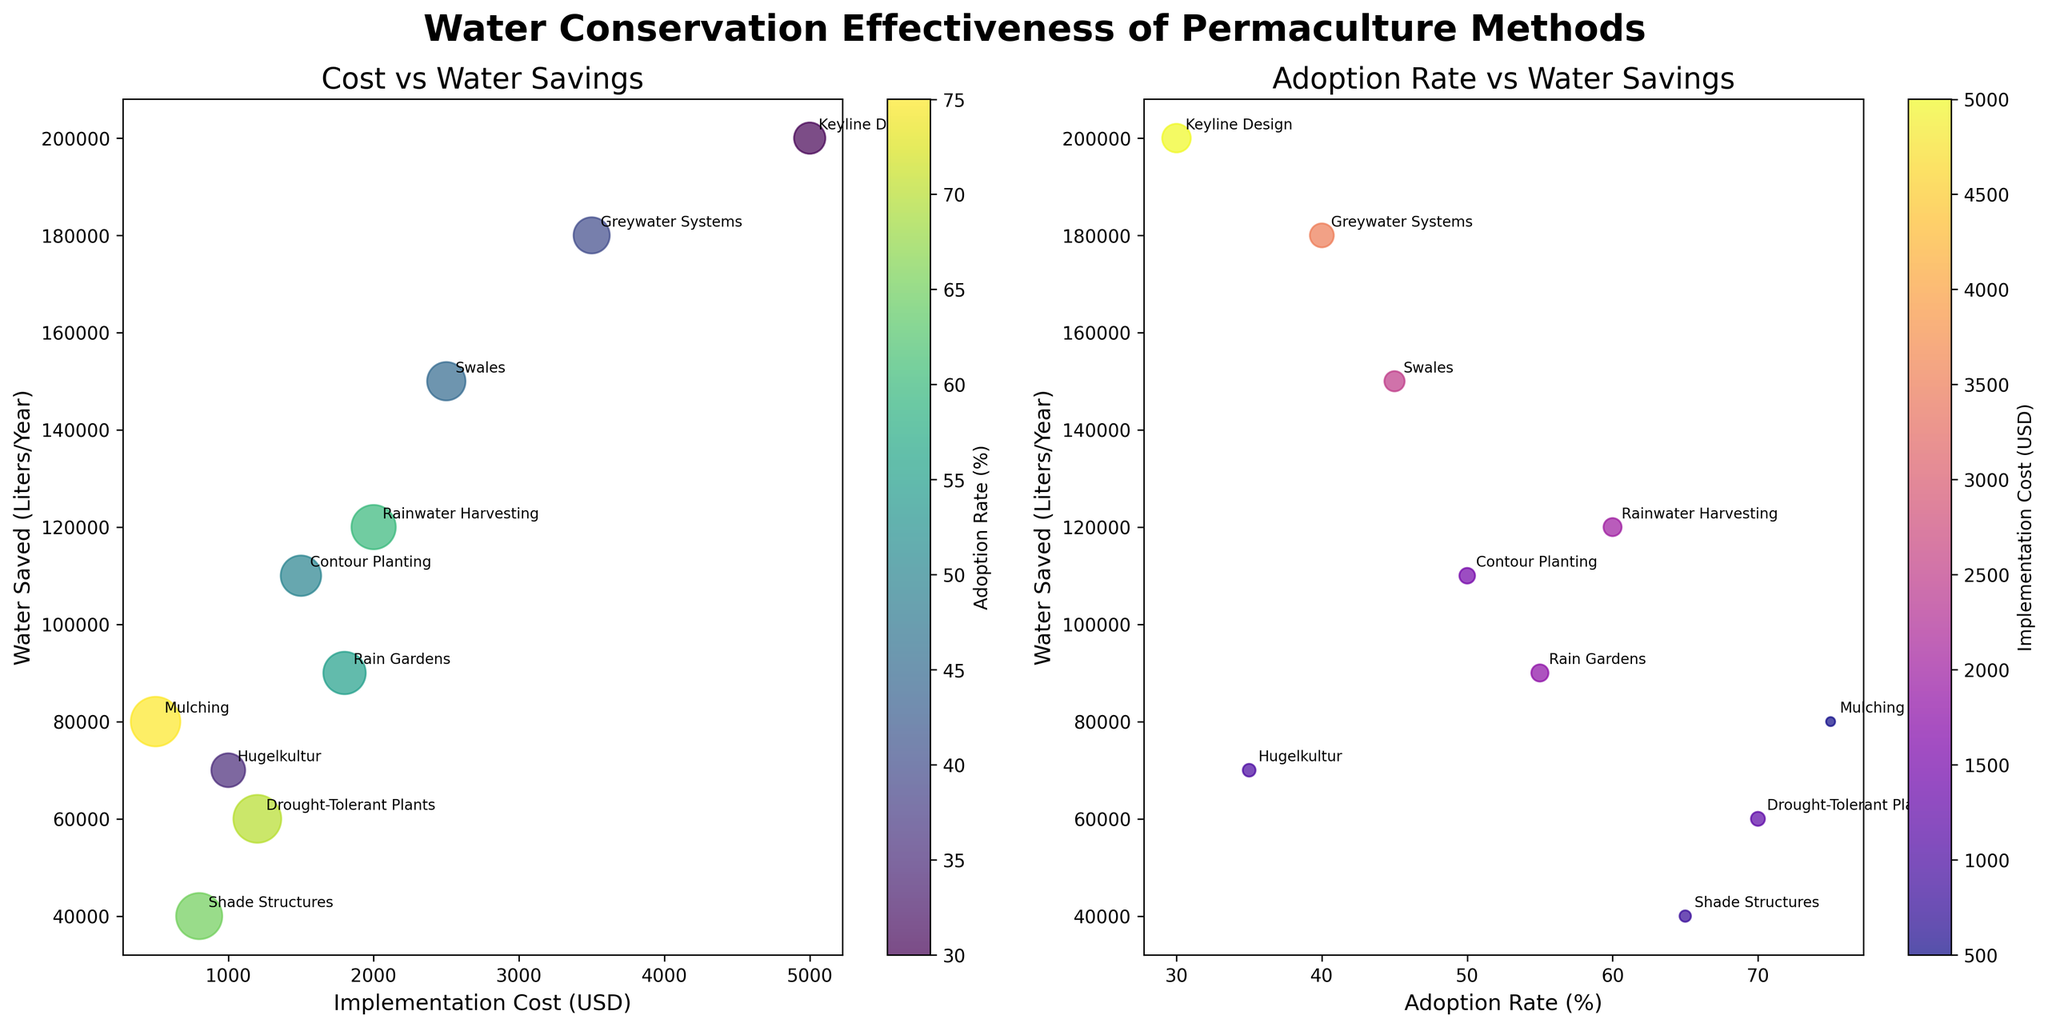How many permaculture methods have an adoption rate of over 50%? Count the dots in the second subplot (Adoption Rate vs Water Savings) with an x-value greater than 50. These are Mulching, Rain Gardens, Rainwater Harvesting, Drought-Tolerant Plants, and Shade Structures.
Answer: 5 Which method has the highest water savings and what is its implementation cost? Look for the highest y-value in both charts. Keyline Design has the highest water savings with 200,000 liters/year. Its implementation cost can be read from the first subplot's x-axis at 5,000 USD.
Answer: Keyline Design, 5,000 USD What is the relationship between implementation cost and adoption rate for Greywater Systems? In the first plot, find the point labeled Greywater Systems and note its size (indicating adoption rate) and x-position (implementation cost). Then, look for it also in the second plot for adoption rate confirmation. Greywater Systems has a moderate adoption rate (40%) with a high implementation cost (3,500 USD).
Answer: Moderate adoption rate, high cost Which regions have permaculture methods with water savings below 90,000 liters/year? By observing both charts, note the regions where the y-value is below 90,000 liters/year. This includes methods like Mulching in Sahel, Hugelkultur in Central Europe, Drought-Tolerant Plants in South Africa, and Shade Structures in North Africa.
Answer: Sahel, Central Europe, South Africa, North Africa Which method has the lowest water savings and what is its adoption rate? Identify the lowest y-value point in both charts, which is for Shade Structures. The adoption rate can be found in the second subplot by looking at the bubble size and corresponding to the color indicating cost.
Answer: Shade Structures, 65% Compare the water savings of Mulching and Keyline Design methods. Which one saves more water and by how much? Note the y-values for Mulching (80,000 liters/year) and Keyline Design (200,000 liters/year) from either plot. Calculate the difference between these values.
Answer: Keyline Design saves 120,000 liters/year more For methods with an implementation cost below 1,000 USD, what is the range of adoption rates? In the first subplot, identify points with an x-value less than 1,000 USD. These are Mulching and Hugelkultur. Check the sizes (adoption rates) of these points. Mulching has a 75% adoption rate, and Hugelkultur has 35%.
Answer: 35%-75% Identify the method with the largest bubble in the first plot. What does this signify about its adoption rate? Find the largest bubble in the first subplot. The size corresponds to the adoption rate, which is highest for Mulching with a 75% adoption rate.
Answer: Mulching, signifies a high adoption rate 